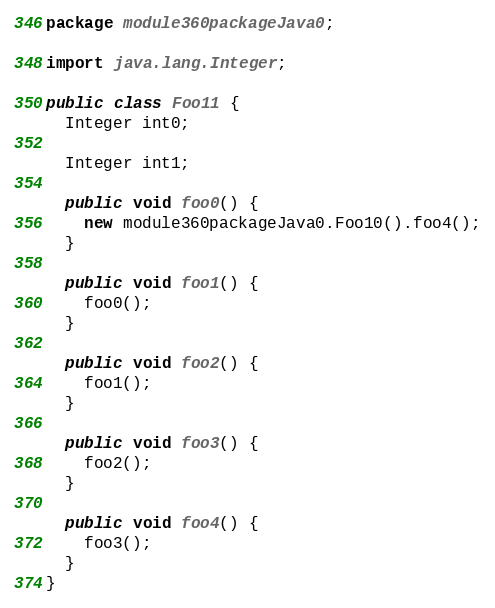<code> <loc_0><loc_0><loc_500><loc_500><_Java_>package module360packageJava0;

import java.lang.Integer;

public class Foo11 {
  Integer int0;

  Integer int1;

  public void foo0() {
    new module360packageJava0.Foo10().foo4();
  }

  public void foo1() {
    foo0();
  }

  public void foo2() {
    foo1();
  }

  public void foo3() {
    foo2();
  }

  public void foo4() {
    foo3();
  }
}
</code> 